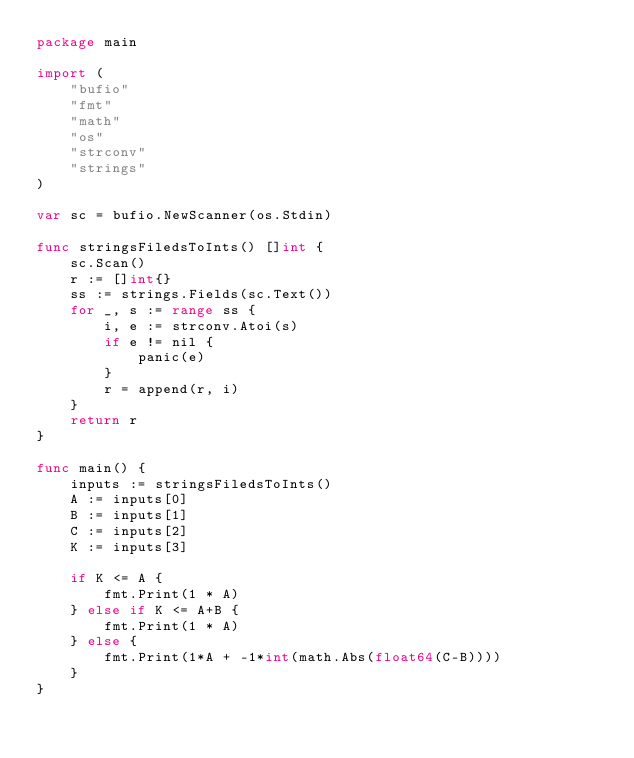Convert code to text. <code><loc_0><loc_0><loc_500><loc_500><_Go_>package main

import (
	"bufio"
	"fmt"
	"math"
	"os"
	"strconv"
	"strings"
)

var sc = bufio.NewScanner(os.Stdin)

func stringsFiledsToInts() []int {
	sc.Scan()
	r := []int{}
	ss := strings.Fields(sc.Text())
	for _, s := range ss {
		i, e := strconv.Atoi(s)
		if e != nil {
			panic(e)
		}
		r = append(r, i)
	}
	return r
}

func main() {
	inputs := stringsFiledsToInts()
	A := inputs[0]
	B := inputs[1]
	C := inputs[2]
	K := inputs[3]

	if K <= A {
		fmt.Print(1 * A)
	} else if K <= A+B {
		fmt.Print(1 * A)
	} else {
		fmt.Print(1*A + -1*int(math.Abs(float64(C-B))))
	}
}
</code> 